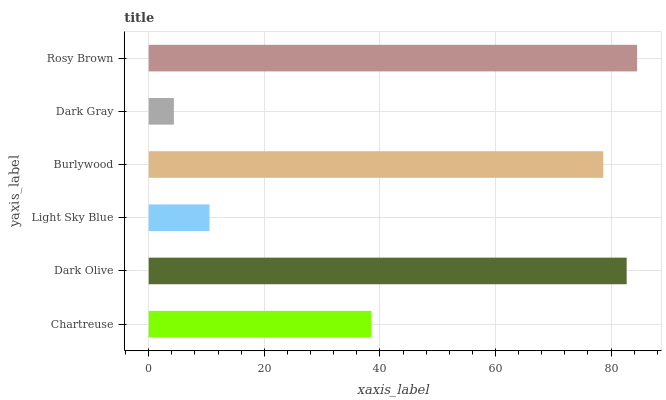Is Dark Gray the minimum?
Answer yes or no. Yes. Is Rosy Brown the maximum?
Answer yes or no. Yes. Is Dark Olive the minimum?
Answer yes or no. No. Is Dark Olive the maximum?
Answer yes or no. No. Is Dark Olive greater than Chartreuse?
Answer yes or no. Yes. Is Chartreuse less than Dark Olive?
Answer yes or no. Yes. Is Chartreuse greater than Dark Olive?
Answer yes or no. No. Is Dark Olive less than Chartreuse?
Answer yes or no. No. Is Burlywood the high median?
Answer yes or no. Yes. Is Chartreuse the low median?
Answer yes or no. Yes. Is Dark Gray the high median?
Answer yes or no. No. Is Dark Olive the low median?
Answer yes or no. No. 